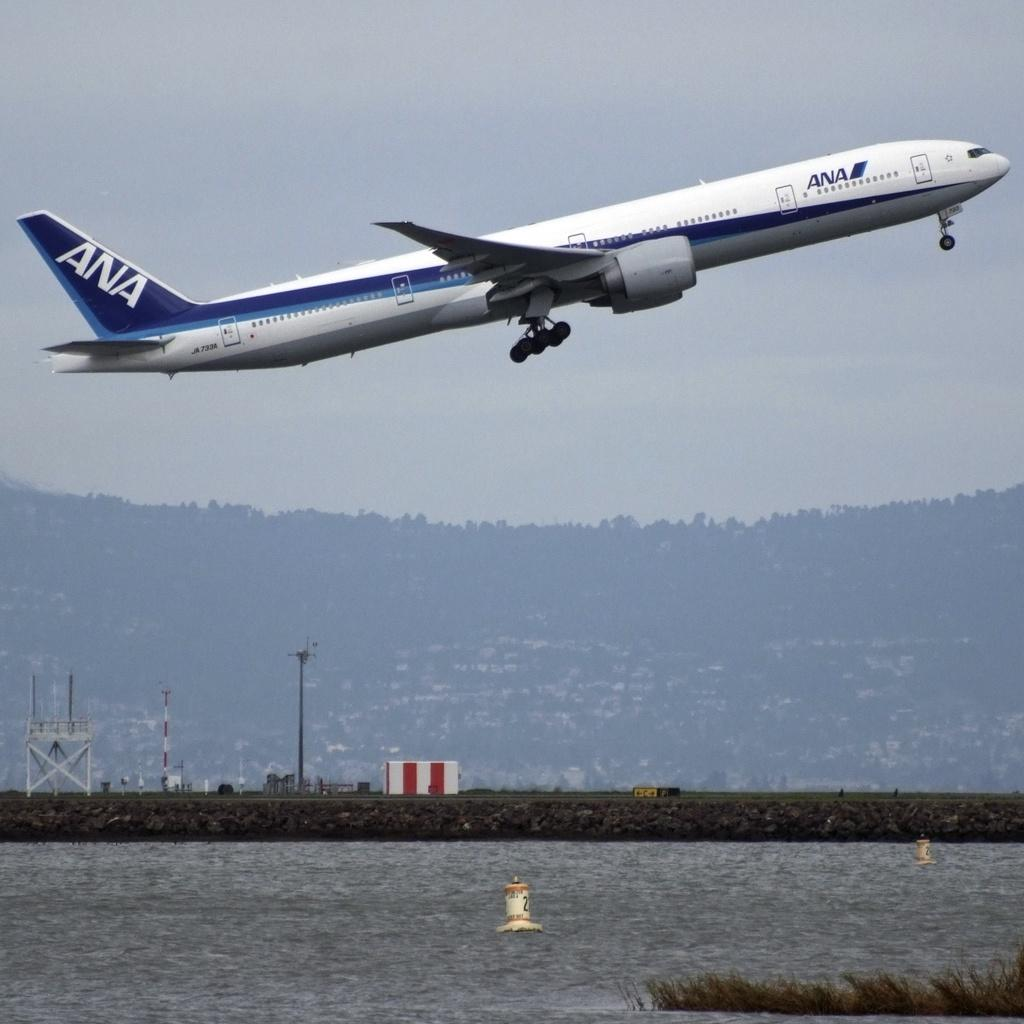<image>
Describe the image concisely. An ANA passenger jet is flying over water. 